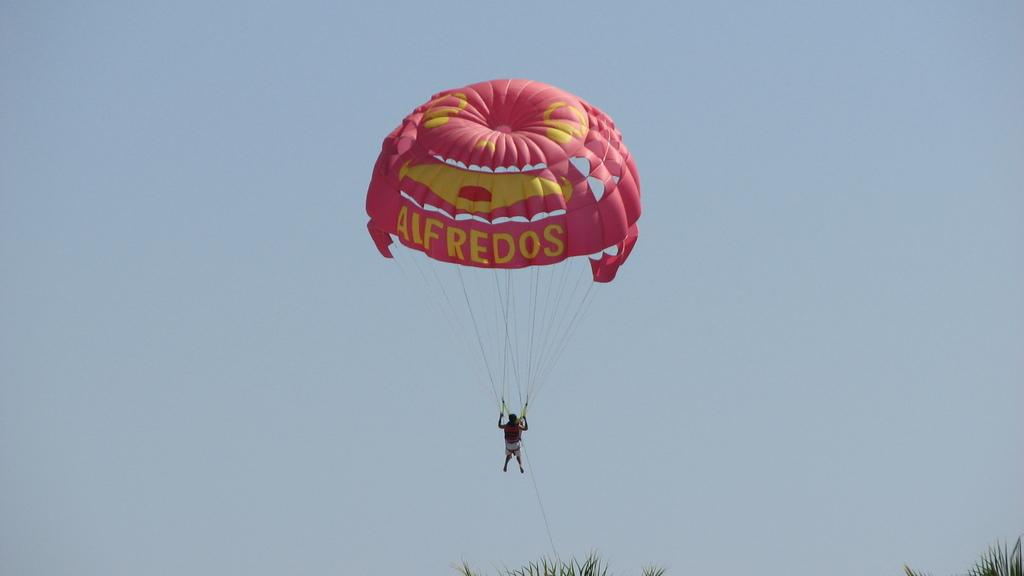What is the main subject of the image? There is a person in the image. What is the person doing in the image? The person is riding on a parachute. What can be seen in the background of the image? There is a sky visible in the background of the image. What type of waste can be seen on the ground in the image? There is no waste visible on the ground in the image; it only shows a person riding on a parachute with a sky background. 